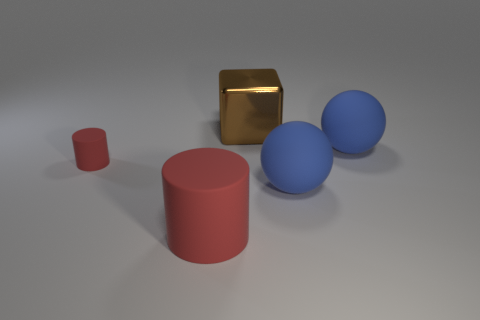Add 1 red cylinders. How many objects exist? 6 Subtract all spheres. How many objects are left? 3 Subtract 0 green cubes. How many objects are left? 5 Subtract all blue metal balls. Subtract all big red objects. How many objects are left? 4 Add 1 red cylinders. How many red cylinders are left? 3 Add 4 big yellow cylinders. How many big yellow cylinders exist? 4 